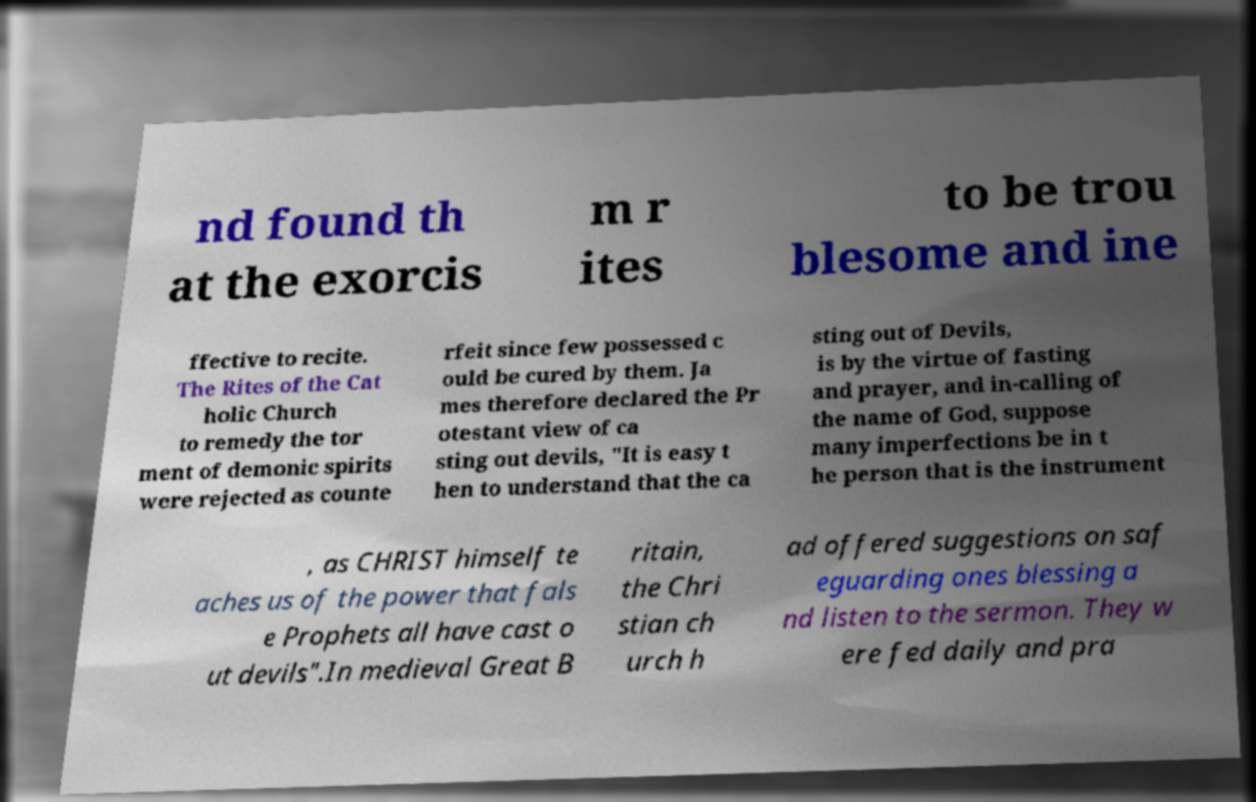Could you extract and type out the text from this image? nd found th at the exorcis m r ites to be trou blesome and ine ffective to recite. The Rites of the Cat holic Church to remedy the tor ment of demonic spirits were rejected as counte rfeit since few possessed c ould be cured by them. Ja mes therefore declared the Pr otestant view of ca sting out devils, "It is easy t hen to understand that the ca sting out of Devils, is by the virtue of fasting and prayer, and in-calling of the name of God, suppose many imperfections be in t he person that is the instrument , as CHRIST himself te aches us of the power that fals e Prophets all have cast o ut devils".In medieval Great B ritain, the Chri stian ch urch h ad offered suggestions on saf eguarding ones blessing a nd listen to the sermon. They w ere fed daily and pra 